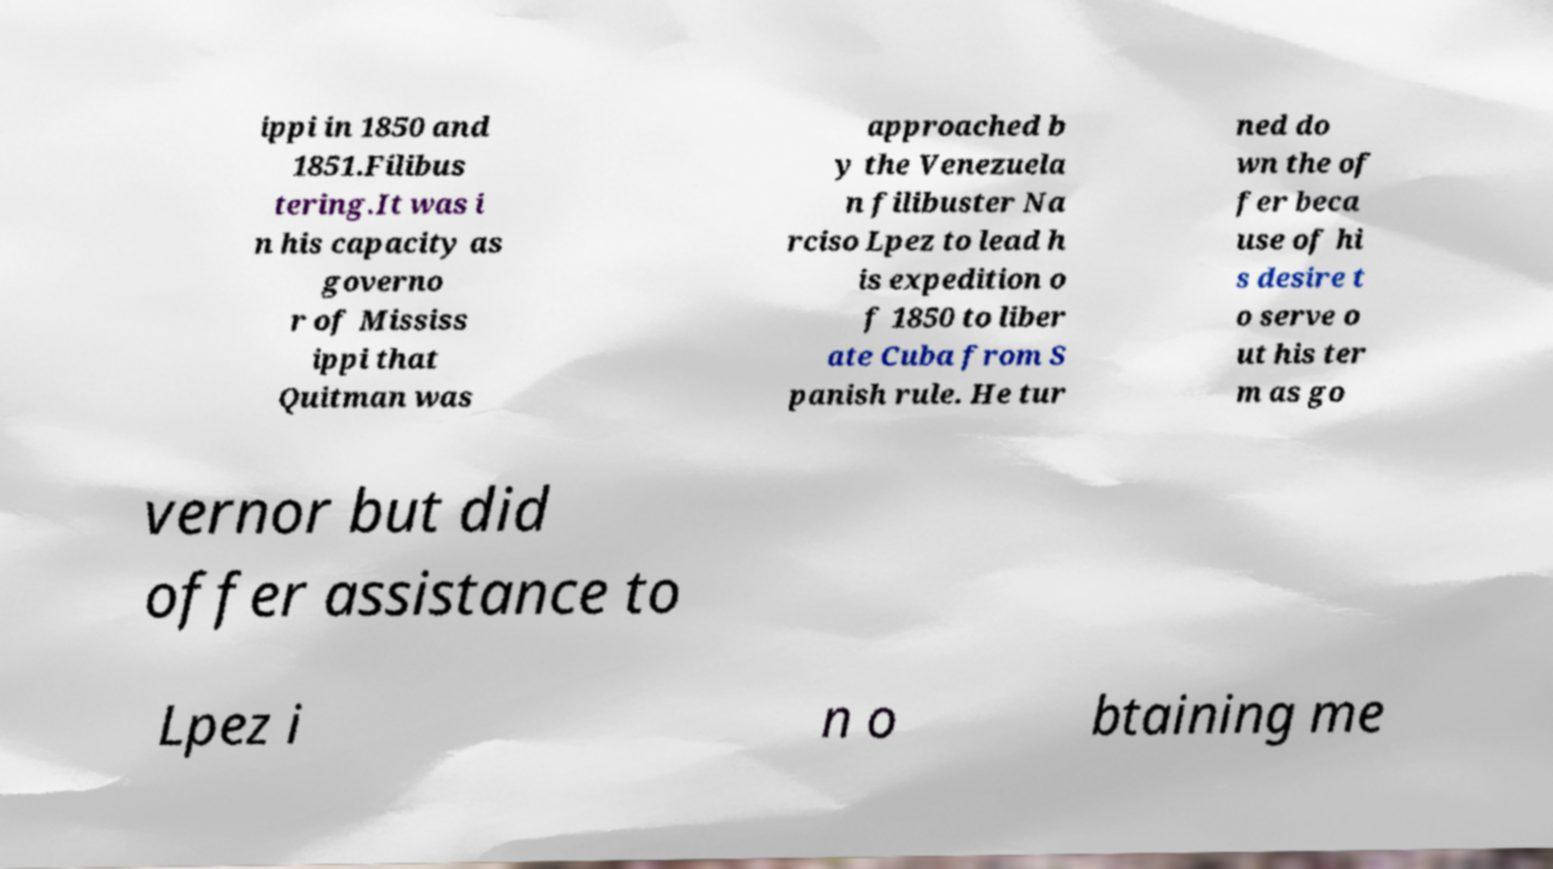Please read and relay the text visible in this image. What does it say? ippi in 1850 and 1851.Filibus tering.It was i n his capacity as governo r of Mississ ippi that Quitman was approached b y the Venezuela n filibuster Na rciso Lpez to lead h is expedition o f 1850 to liber ate Cuba from S panish rule. He tur ned do wn the of fer beca use of hi s desire t o serve o ut his ter m as go vernor but did offer assistance to Lpez i n o btaining me 